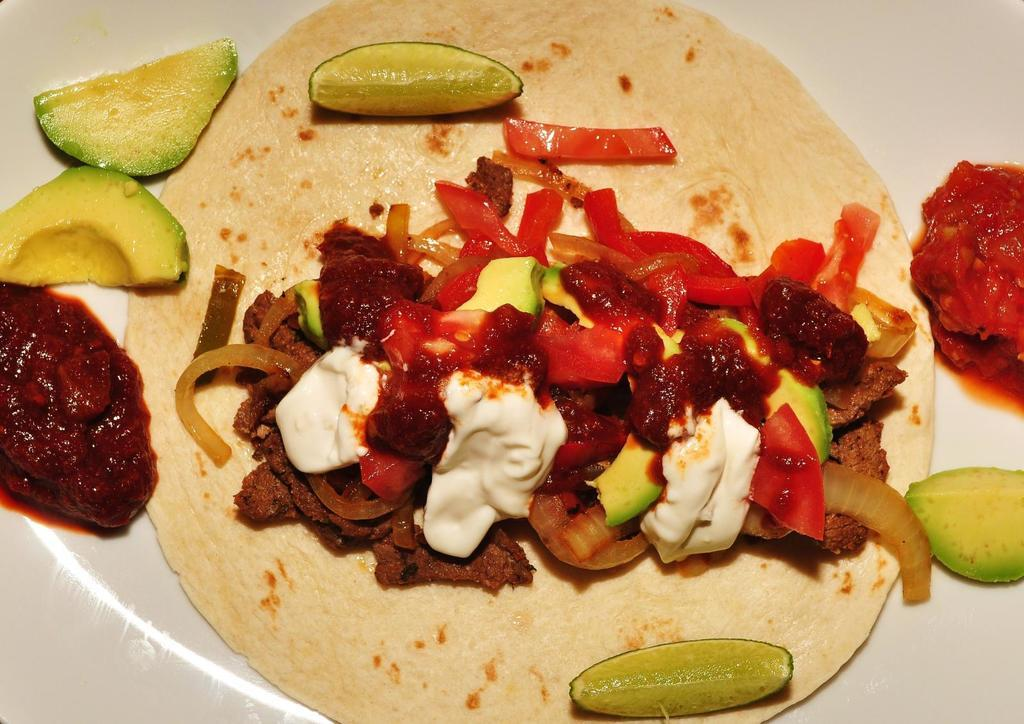What is present on the plate in the image? There are tomatoes and onions in the plate. Can you describe the contents of the plate in more detail? The plate contains tomatoes and onions, which are both vegetables. What type of land can be seen in the image? There is no land visible in the image; it only shows a plate with tomatoes and onions. 